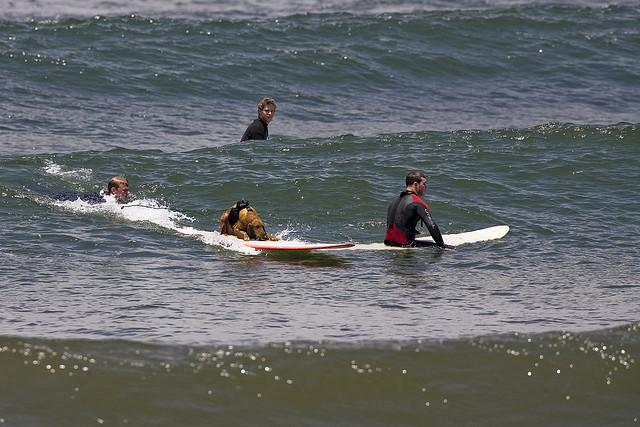What is the dog doing? Please explain your reasoning. surfing. A dog is on surfboard in the water. 